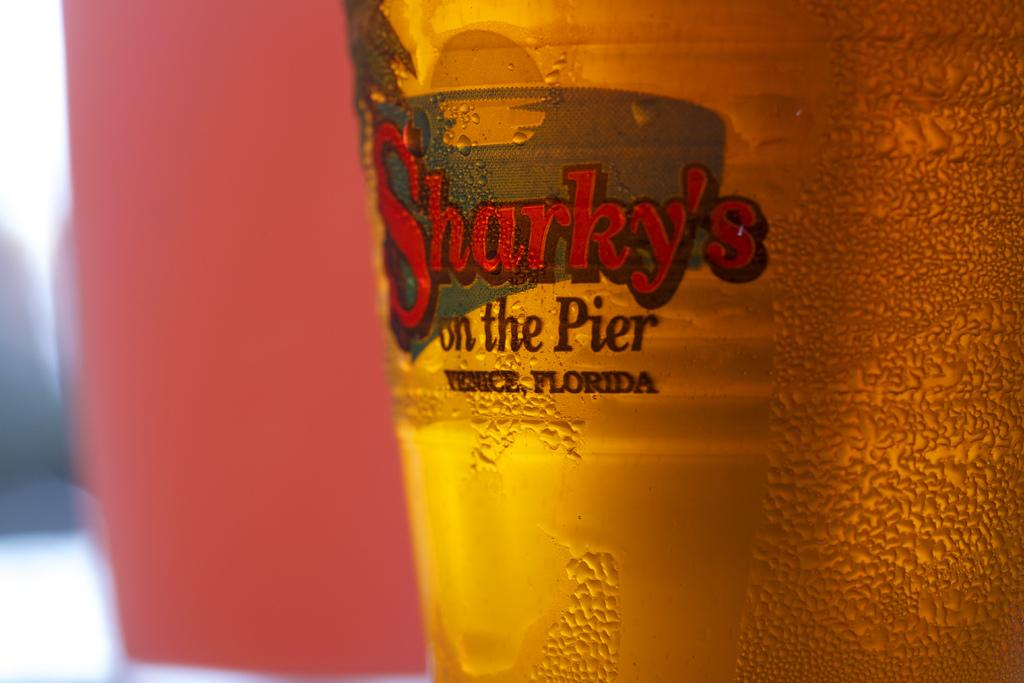<image>
Render a clear and concise summary of the photo. A bottle of Sharky's on the Pier beer shows it 